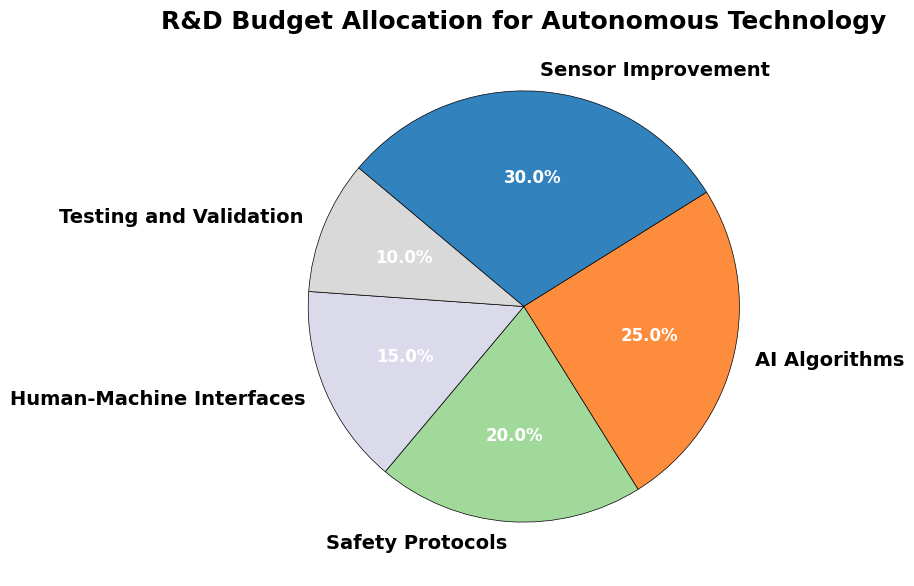What category has the highest percentage of the R&D budget allocation? By observing the pie chart, the segment with the largest wedge represents the category with the highest percentage. The "Sensor Improvement" category has the largest section in the pie chart.
Answer: Sensor Improvement Which category has the smallest percentage of the R&D budget allocation? By looking at the pie chart, the smallest wedge represents the category with the lowest percentage. The "Testing and Validation" category is the smallest segment.
Answer: Testing and Validation What is the total percentage allocated to "AI Algorithms" and "Safety Protocols"? To find this, add the percentages for "AI Algorithms" and "Safety Protocols": 25% + 20% = 45%.
Answer: 45% How much more percentage is allocated to "Sensor Improvement" compared to "Human-Machine Interfaces"? Subtract the percentage of "Human-Machine Interfaces" from "Sensor Improvement": 30% - 15% = 15%.
Answer: 15% Are there any categories that have an equal percentage of the R&D budget allocation? By evaluating the pie chart, there are no categories that have the same percentage as all percentages are different.
Answer: No What is the difference in percentage allocation between "AI Algorithms" and "Testing and Validation"? Subtract the percentage of "Testing and Validation" from "AI Algorithms": 25% - 10% = 15%.
Answer: 15% What is the combined percentage of the three smallest categories? Add the percentages of "Human-Machine Interfaces", "Safety Protocols", and "Testing and Validation": 15% + 20% + 10% = 45%.
Answer: 45% Which category is allocated less than 20%? Identify any category with a percentage less than 20%. "Testing and Validation" (10%) and "Human-Machine Interfaces" (15%) fall under this criterion.
Answer: Testing and Validation, Human-Machine Interfaces Identify the second most allocated category for the R&D budget. By observing the size of the pie wedges and their corresponding percentages, the second largest percentage allocation is for "AI Algorithms" with 25%.
Answer: AI Algorithms How many more percentage points are allocated to "Sensor Improvement" compared to "AI Algorithms"? Subtract the percentage of "AI Algorithms" from "Sensor Improvement": 30% - 25% = 5%.
Answer: 5% 